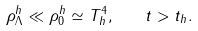<formula> <loc_0><loc_0><loc_500><loc_500>\rho ^ { h } _ { \Lambda } \ll \rho _ { 0 } ^ { h } \simeq T _ { h } ^ { 4 } , \quad t > t _ { h } .</formula> 